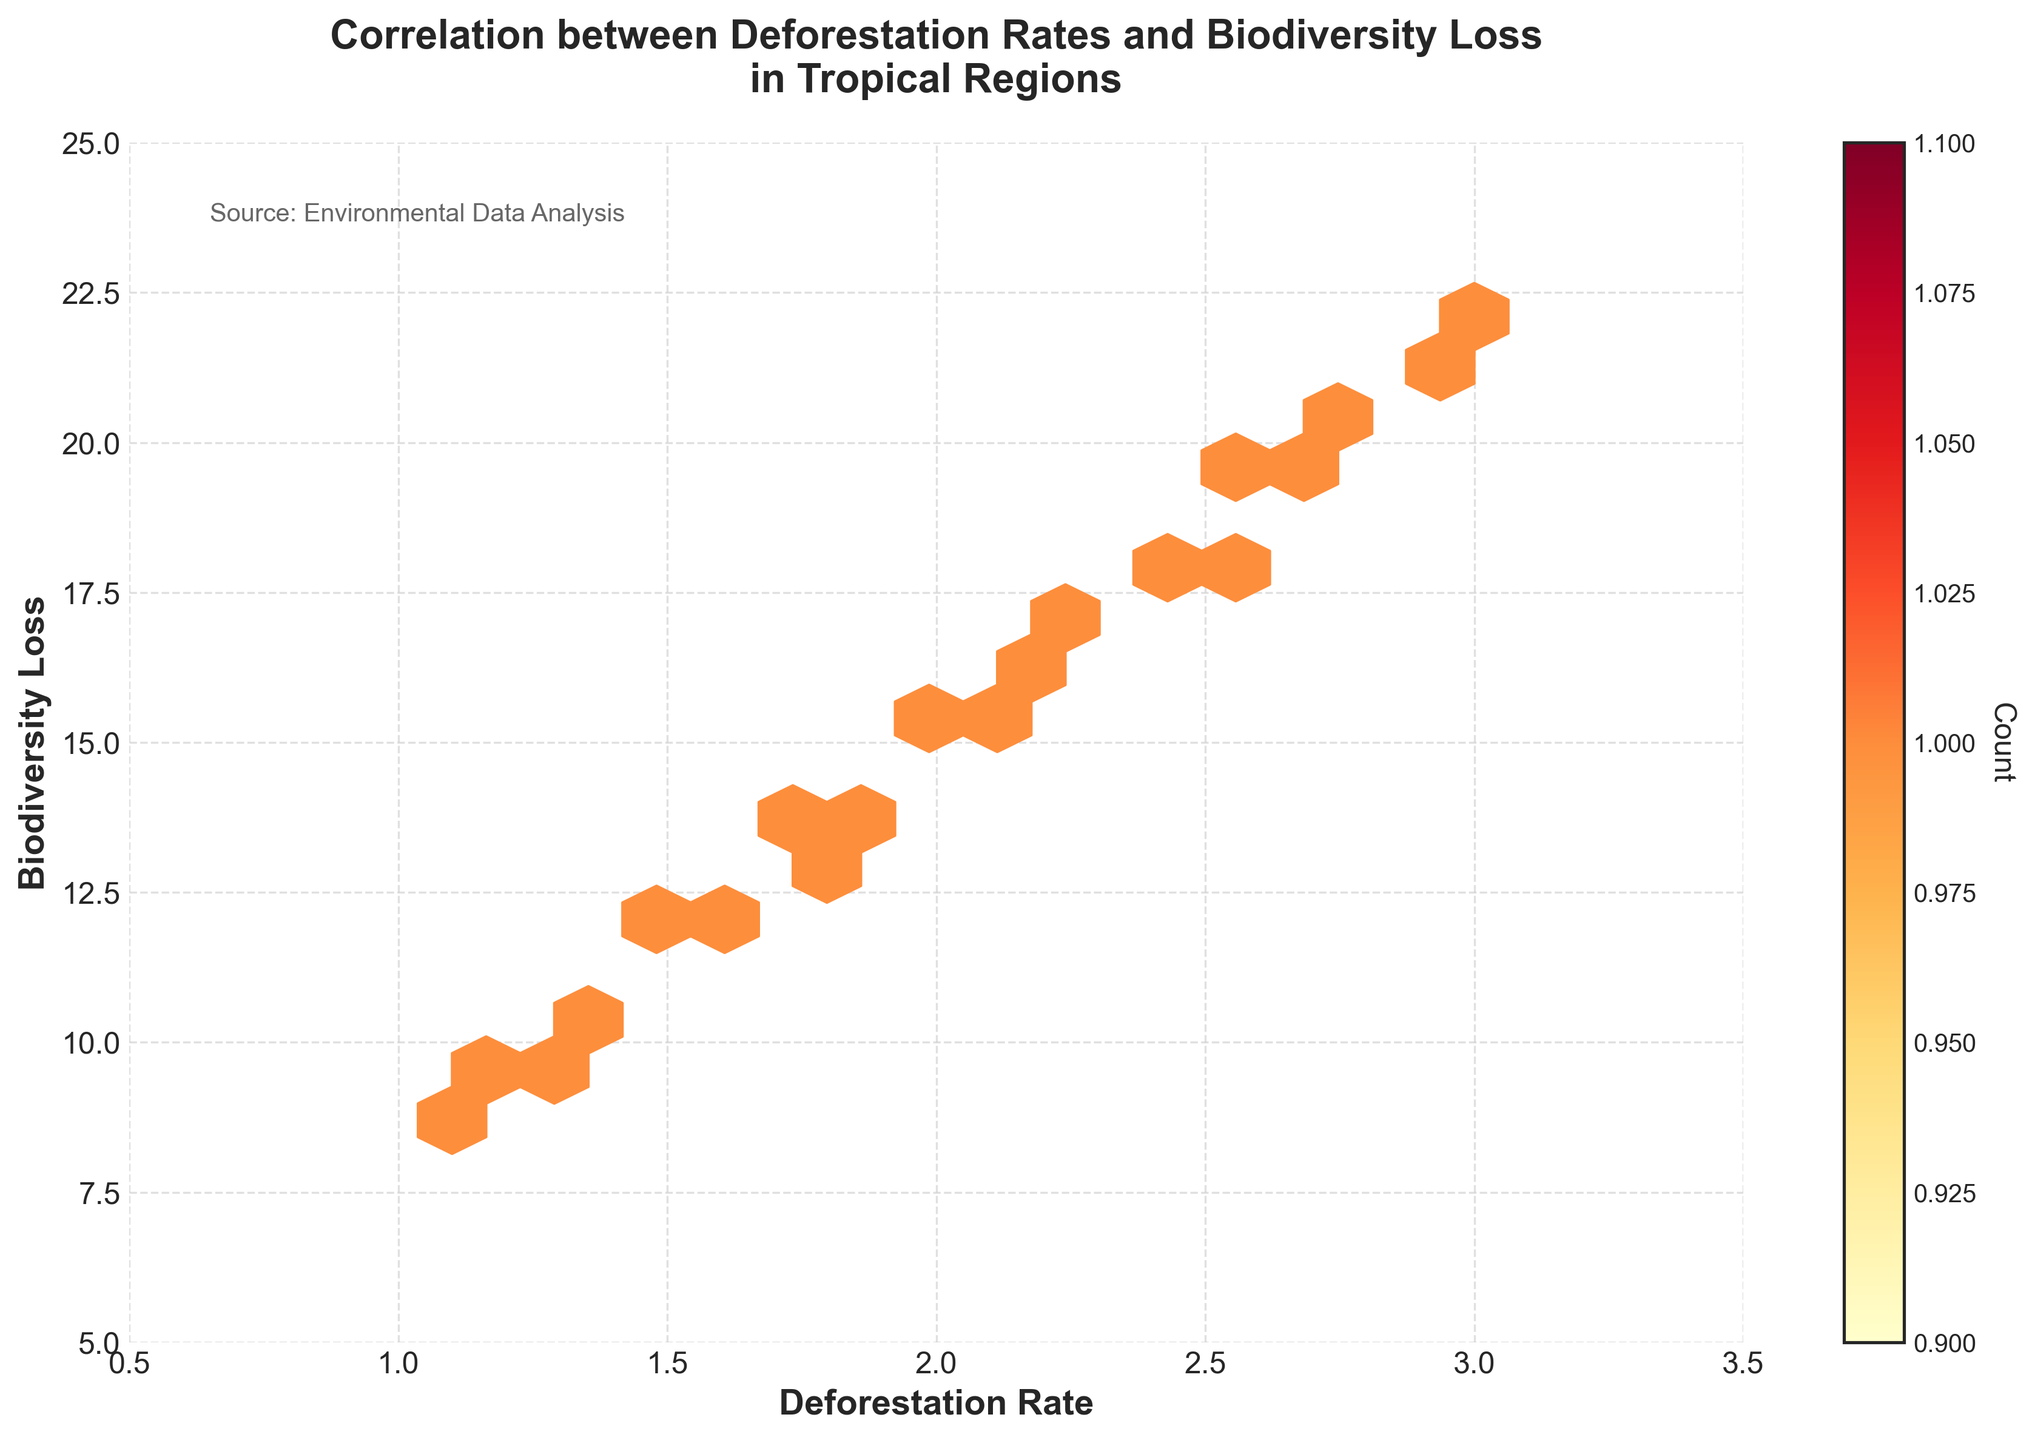What is the title of the hexbin plot? The title is located at the top center of the plot. It provides a summary of what the plot represents. The title reads 'Correlation between Deforestation Rates and Biodiversity Loss in Tropical Regions'.
Answer: Correlation between Deforestation Rates and Biodiversity Loss in Tropical Regions What are the X and Y axis labels? The X-axis label is 'Deforestation Rate', and the Y-axis label is 'Biodiversity Loss'. These labels are located below the X-axis and beside the Y-axis, respectively.
Answer: Deforestation Rate, Biodiversity Loss What color scheme is used in the hexbin plot? The plot uses a gradient color scheme that shifts from yellow to orange to red, indicating varying densities. This color scheme is often referred to as 'YlOrRd'.
Answer: Yellow to Orange to Red How does the color intensity of the hexagons relate to the data? The color intensity of each hexagon indicates the number of data points within that hexagon. A deeper (more intense) color means a higher concentration of data points.
Answer: More intense color indicates higher data density What is the range of the X-axis and the Y-axis? The X-axis ranges from 0.5 to 3.5, and the Y-axis ranges from 5 to 25. These ranges are visible through the ticks and labels on the axes.
Answer: X-axis: 0.5 to 3.5, Y-axis: 5 to 25 How many hexagons are in the plot? To determine the number of hexagons, you count all the hexagons visible in the plot. The gridsize parameter suggests about 15 hexagons per row, but counting visible hexagons would be precise.
Answer: Varies (approximately 200-300) Which region has the highest deforestation rate, and what is its biodiversity loss? Indonesia shows the highest deforestation rate at 3.0, and its corresponding biodiversity loss is 22.1. The exact values can be identified from the data points.
Answer: Indonesia, 22.1 Identify a region with a deforestation rate below 2.0 and state its biodiversity loss. Madagascar has a deforestation rate of 1.2, and its biodiversity loss is 9.5. This is identified from the data points within the specified deforestation rate range.
Answer: Madagascar, 9.5 Is there a visible trend between deforestation rates and biodiversity loss? Upon visual inspection, there appears to be a positive correlation (direct relationship), where higher deforestation rates generally coincide with higher biodiversity loss. This can be inferred by observing the distribution and density of the hexagons along the diagonal.
Answer: Yes, a positive correlation What information is provided by the color bar? The color bar, located on the right side of the plot, provides a scale for interpreting the color intensity of the hexagons. It indicates the count of data points within a hexagon, with deeper colors representing higher counts.
Answer: Count of data points Which section of the plot has the least concentration of data points? The sections with the lightest color (yellow) represent the areas with the least concentration of data points. Specifically, the lower left (near deforestation rates below 1.5 and biodiversity loss below 10) and upper right (deforestation rates above 3.0).
Answer: Lower left and upper right 